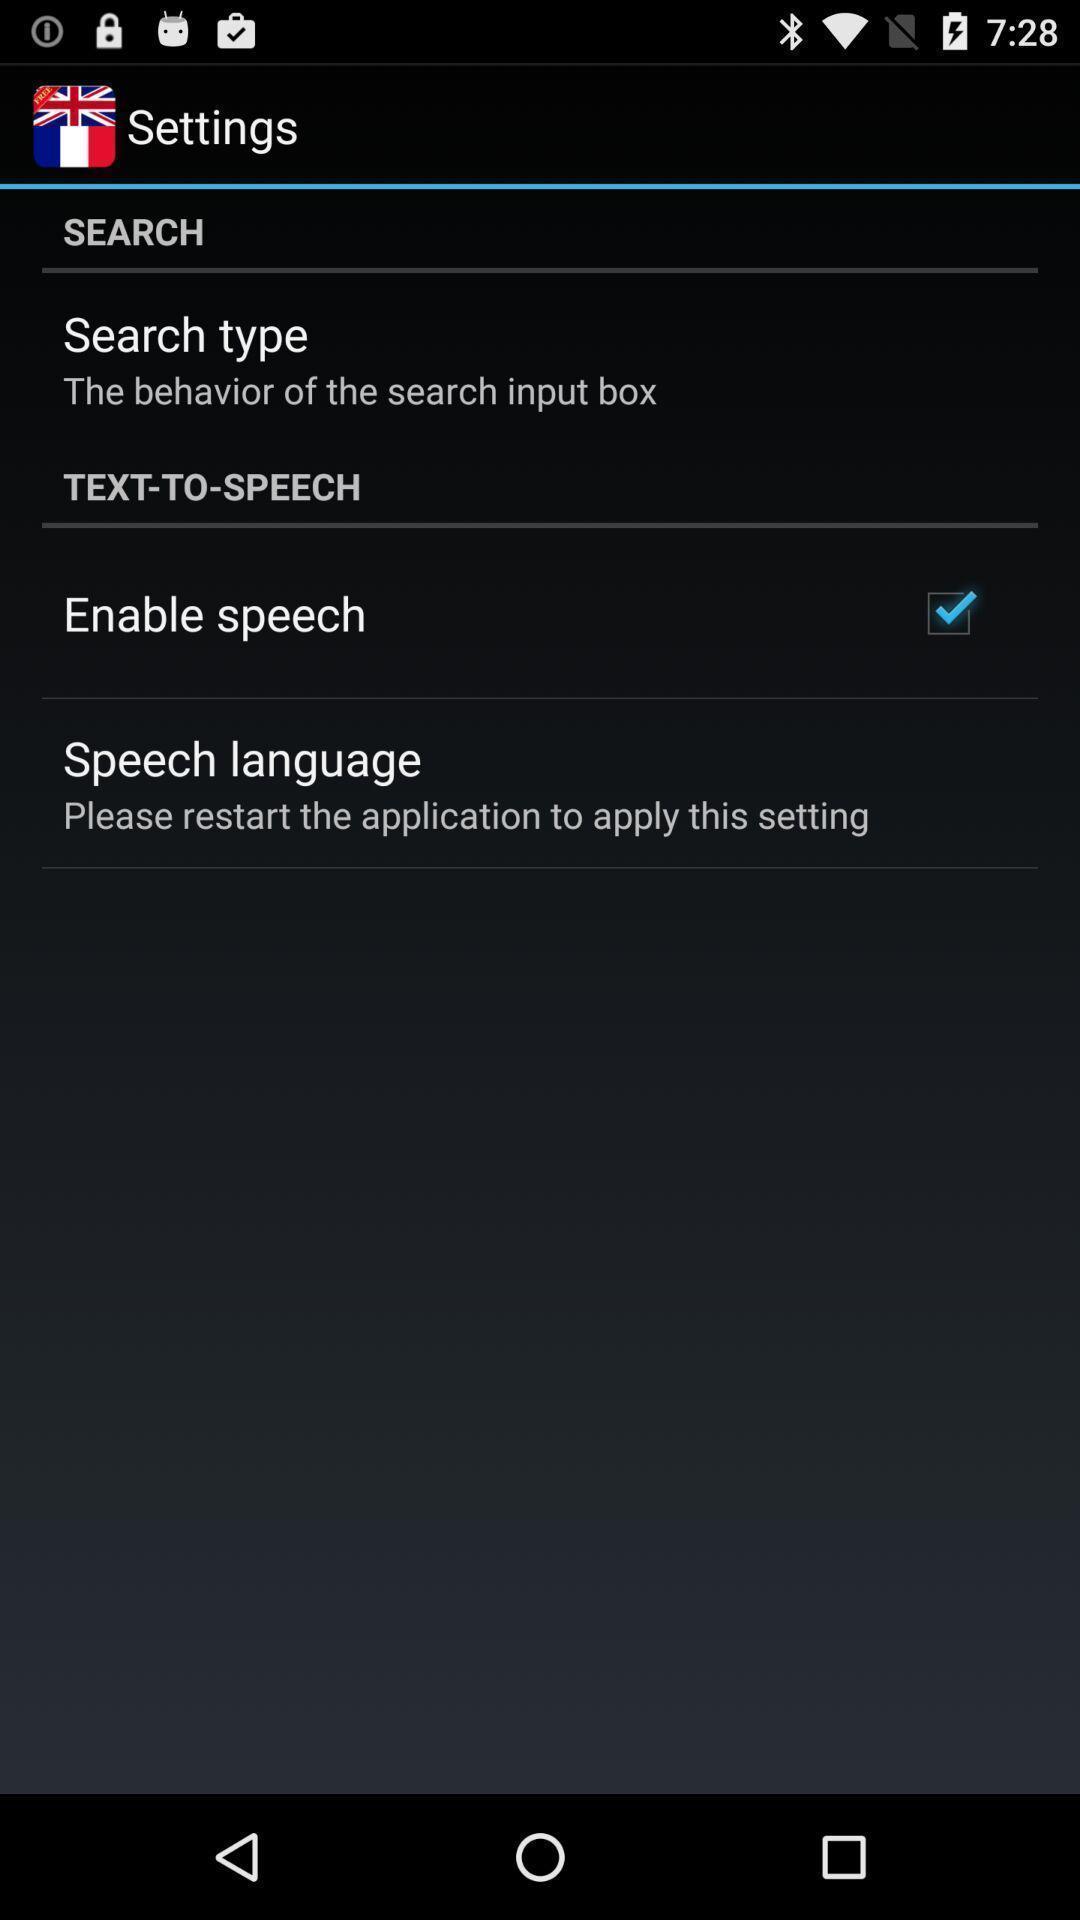Tell me about the visual elements in this screen capture. Screen displaying search bar under settings. 